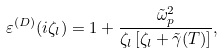<formula> <loc_0><loc_0><loc_500><loc_500>\varepsilon ^ { ( D ) } ( i \zeta _ { l } ) = 1 + \frac { { \tilde { \omega } } _ { p } ^ { 2 } } { \zeta _ { l } \left [ \zeta _ { l } + { \tilde { \gamma } } ( T ) \right ] } ,</formula> 